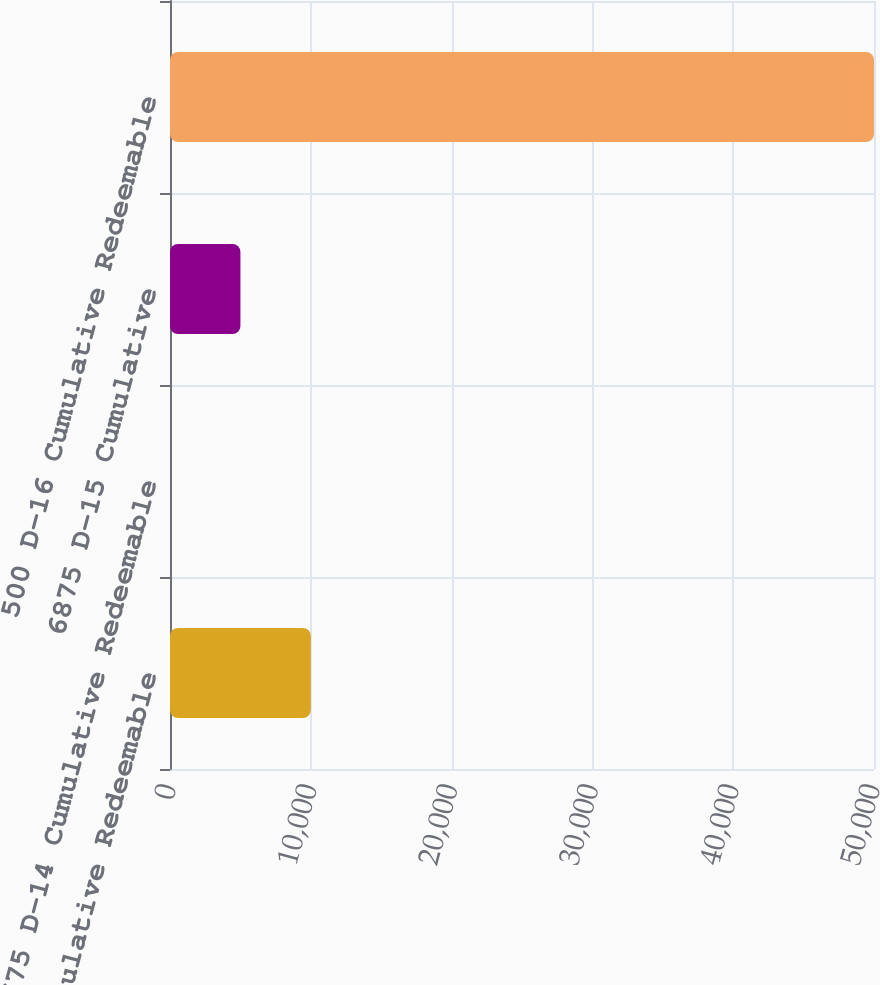Convert chart to OTSL. <chart><loc_0><loc_0><loc_500><loc_500><bar_chart><fcel>700 D-10 Cumulative Redeemable<fcel>675 D-14 Cumulative Redeemable<fcel>6875 D-15 Cumulative<fcel>500 D-16 Cumulative Redeemable<nl><fcel>10001.4<fcel>1.69<fcel>5001.52<fcel>50000<nl></chart> 